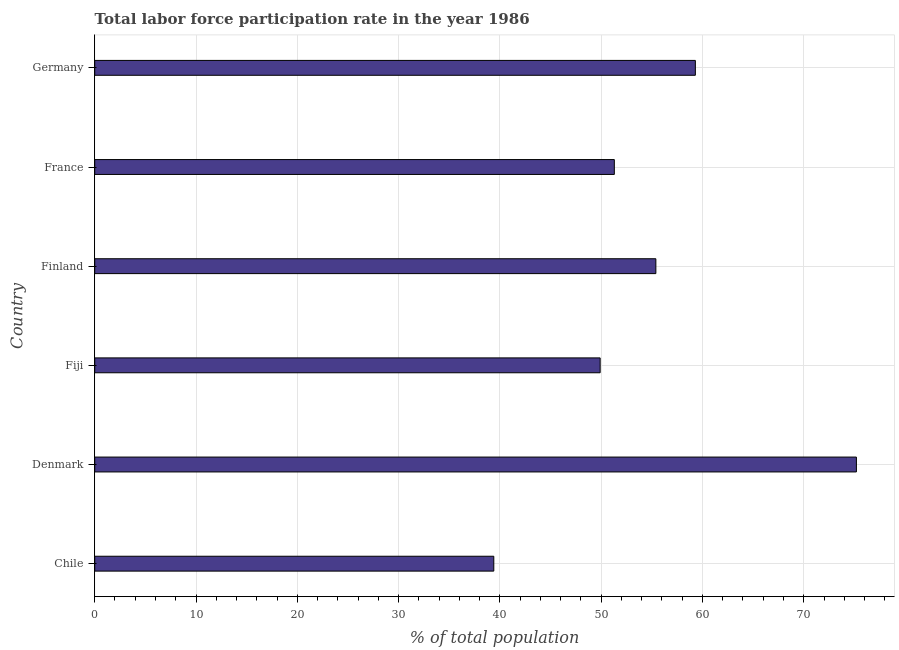Does the graph contain any zero values?
Offer a terse response. No. What is the title of the graph?
Your answer should be very brief. Total labor force participation rate in the year 1986. What is the label or title of the X-axis?
Offer a terse response. % of total population. What is the total labor force participation rate in Fiji?
Your response must be concise. 49.9. Across all countries, what is the maximum total labor force participation rate?
Provide a short and direct response. 75.2. Across all countries, what is the minimum total labor force participation rate?
Give a very brief answer. 39.4. In which country was the total labor force participation rate maximum?
Ensure brevity in your answer.  Denmark. What is the sum of the total labor force participation rate?
Give a very brief answer. 330.5. What is the difference between the total labor force participation rate in Finland and Germany?
Make the answer very short. -3.9. What is the average total labor force participation rate per country?
Keep it short and to the point. 55.08. What is the median total labor force participation rate?
Keep it short and to the point. 53.35. In how many countries, is the total labor force participation rate greater than 30 %?
Ensure brevity in your answer.  6. What is the ratio of the total labor force participation rate in Chile to that in Denmark?
Provide a short and direct response. 0.52. What is the difference between the highest and the second highest total labor force participation rate?
Ensure brevity in your answer.  15.9. Is the sum of the total labor force participation rate in Denmark and France greater than the maximum total labor force participation rate across all countries?
Your answer should be very brief. Yes. What is the difference between the highest and the lowest total labor force participation rate?
Ensure brevity in your answer.  35.8. Are all the bars in the graph horizontal?
Offer a very short reply. Yes. What is the difference between two consecutive major ticks on the X-axis?
Offer a very short reply. 10. Are the values on the major ticks of X-axis written in scientific E-notation?
Ensure brevity in your answer.  No. What is the % of total population of Chile?
Keep it short and to the point. 39.4. What is the % of total population of Denmark?
Ensure brevity in your answer.  75.2. What is the % of total population of Fiji?
Your response must be concise. 49.9. What is the % of total population of Finland?
Offer a very short reply. 55.4. What is the % of total population in France?
Your answer should be compact. 51.3. What is the % of total population in Germany?
Offer a very short reply. 59.3. What is the difference between the % of total population in Chile and Denmark?
Provide a succinct answer. -35.8. What is the difference between the % of total population in Chile and Fiji?
Provide a short and direct response. -10.5. What is the difference between the % of total population in Chile and Finland?
Provide a succinct answer. -16. What is the difference between the % of total population in Chile and Germany?
Offer a very short reply. -19.9. What is the difference between the % of total population in Denmark and Fiji?
Make the answer very short. 25.3. What is the difference between the % of total population in Denmark and Finland?
Your response must be concise. 19.8. What is the difference between the % of total population in Denmark and France?
Provide a succinct answer. 23.9. What is the difference between the % of total population in Denmark and Germany?
Provide a succinct answer. 15.9. What is the difference between the % of total population in Fiji and France?
Provide a short and direct response. -1.4. What is the difference between the % of total population in Finland and Germany?
Your response must be concise. -3.9. What is the ratio of the % of total population in Chile to that in Denmark?
Offer a very short reply. 0.52. What is the ratio of the % of total population in Chile to that in Fiji?
Make the answer very short. 0.79. What is the ratio of the % of total population in Chile to that in Finland?
Offer a terse response. 0.71. What is the ratio of the % of total population in Chile to that in France?
Offer a very short reply. 0.77. What is the ratio of the % of total population in Chile to that in Germany?
Keep it short and to the point. 0.66. What is the ratio of the % of total population in Denmark to that in Fiji?
Provide a succinct answer. 1.51. What is the ratio of the % of total population in Denmark to that in Finland?
Offer a very short reply. 1.36. What is the ratio of the % of total population in Denmark to that in France?
Your response must be concise. 1.47. What is the ratio of the % of total population in Denmark to that in Germany?
Provide a succinct answer. 1.27. What is the ratio of the % of total population in Fiji to that in Finland?
Provide a short and direct response. 0.9. What is the ratio of the % of total population in Fiji to that in Germany?
Your response must be concise. 0.84. What is the ratio of the % of total population in Finland to that in Germany?
Your response must be concise. 0.93. What is the ratio of the % of total population in France to that in Germany?
Offer a very short reply. 0.86. 